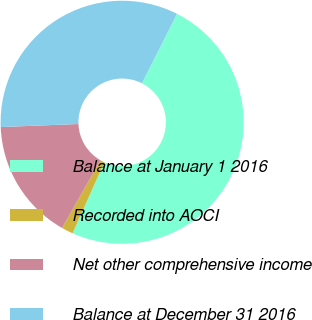Convert chart. <chart><loc_0><loc_0><loc_500><loc_500><pie_chart><fcel>Balance at January 1 2016<fcel>Recorded into AOCI<fcel>Net other comprehensive income<fcel>Balance at December 31 2016<nl><fcel>49.23%<fcel>1.54%<fcel>16.15%<fcel>33.08%<nl></chart> 